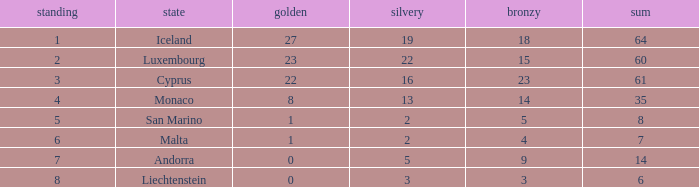Where does Iceland rank with under 19 silvers? None. Parse the full table. {'header': ['standing', 'state', 'golden', 'silvery', 'bronzy', 'sum'], 'rows': [['1', 'Iceland', '27', '19', '18', '64'], ['2', 'Luxembourg', '23', '22', '15', '60'], ['3', 'Cyprus', '22', '16', '23', '61'], ['4', 'Monaco', '8', '13', '14', '35'], ['5', 'San Marino', '1', '2', '5', '8'], ['6', 'Malta', '1', '2', '4', '7'], ['7', 'Andorra', '0', '5', '9', '14'], ['8', 'Liechtenstein', '0', '3', '3', '6']]} 